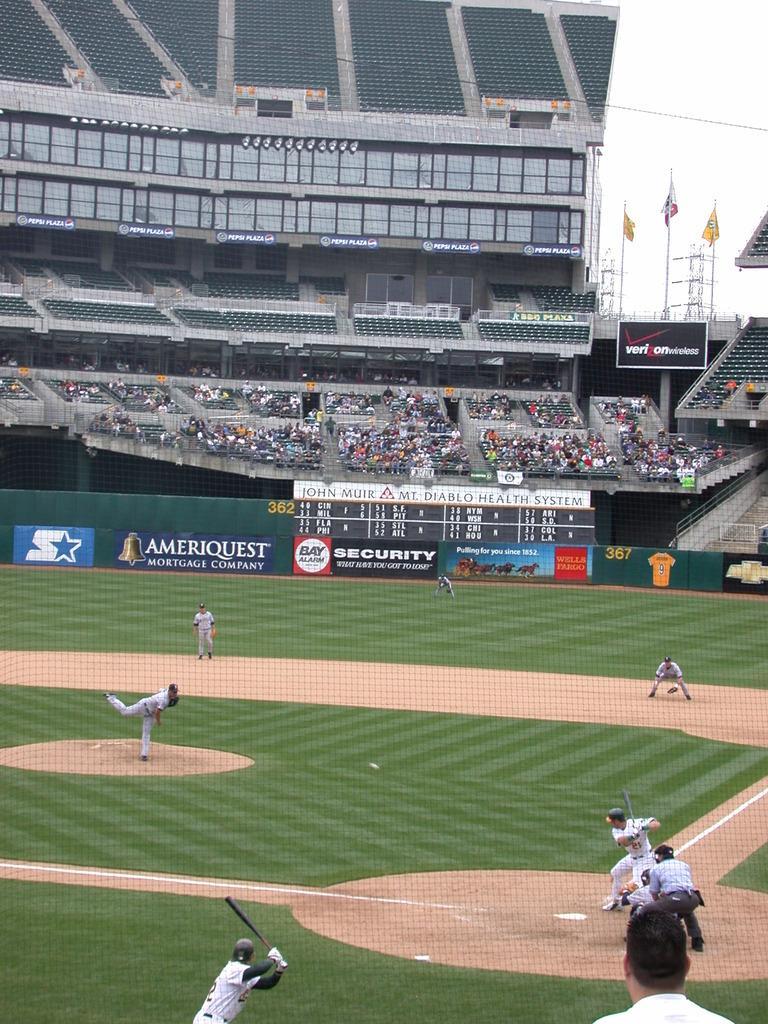Describe this image in one or two sentences. In this image we can see a group of people standing on the ground. In that two people are holding the bats. We can also see a fence with some text on it, a staircase, a group of audience, the flags, poles, the boards with some text on them, the metal frames and the sky. 